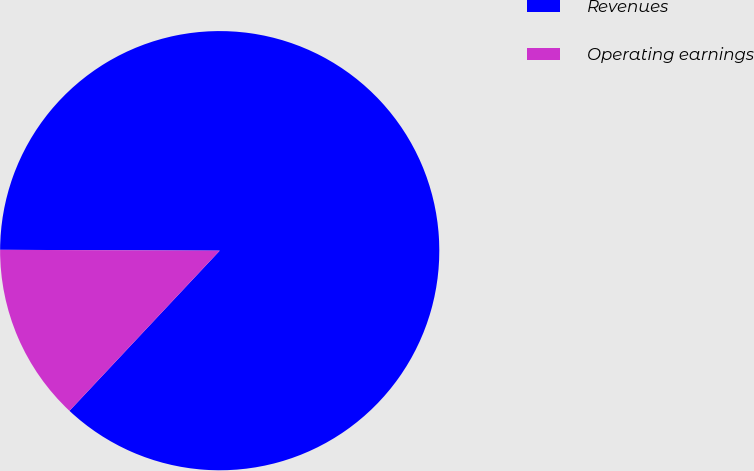Convert chart. <chart><loc_0><loc_0><loc_500><loc_500><pie_chart><fcel>Revenues<fcel>Operating earnings<nl><fcel>86.93%<fcel>13.07%<nl></chart> 